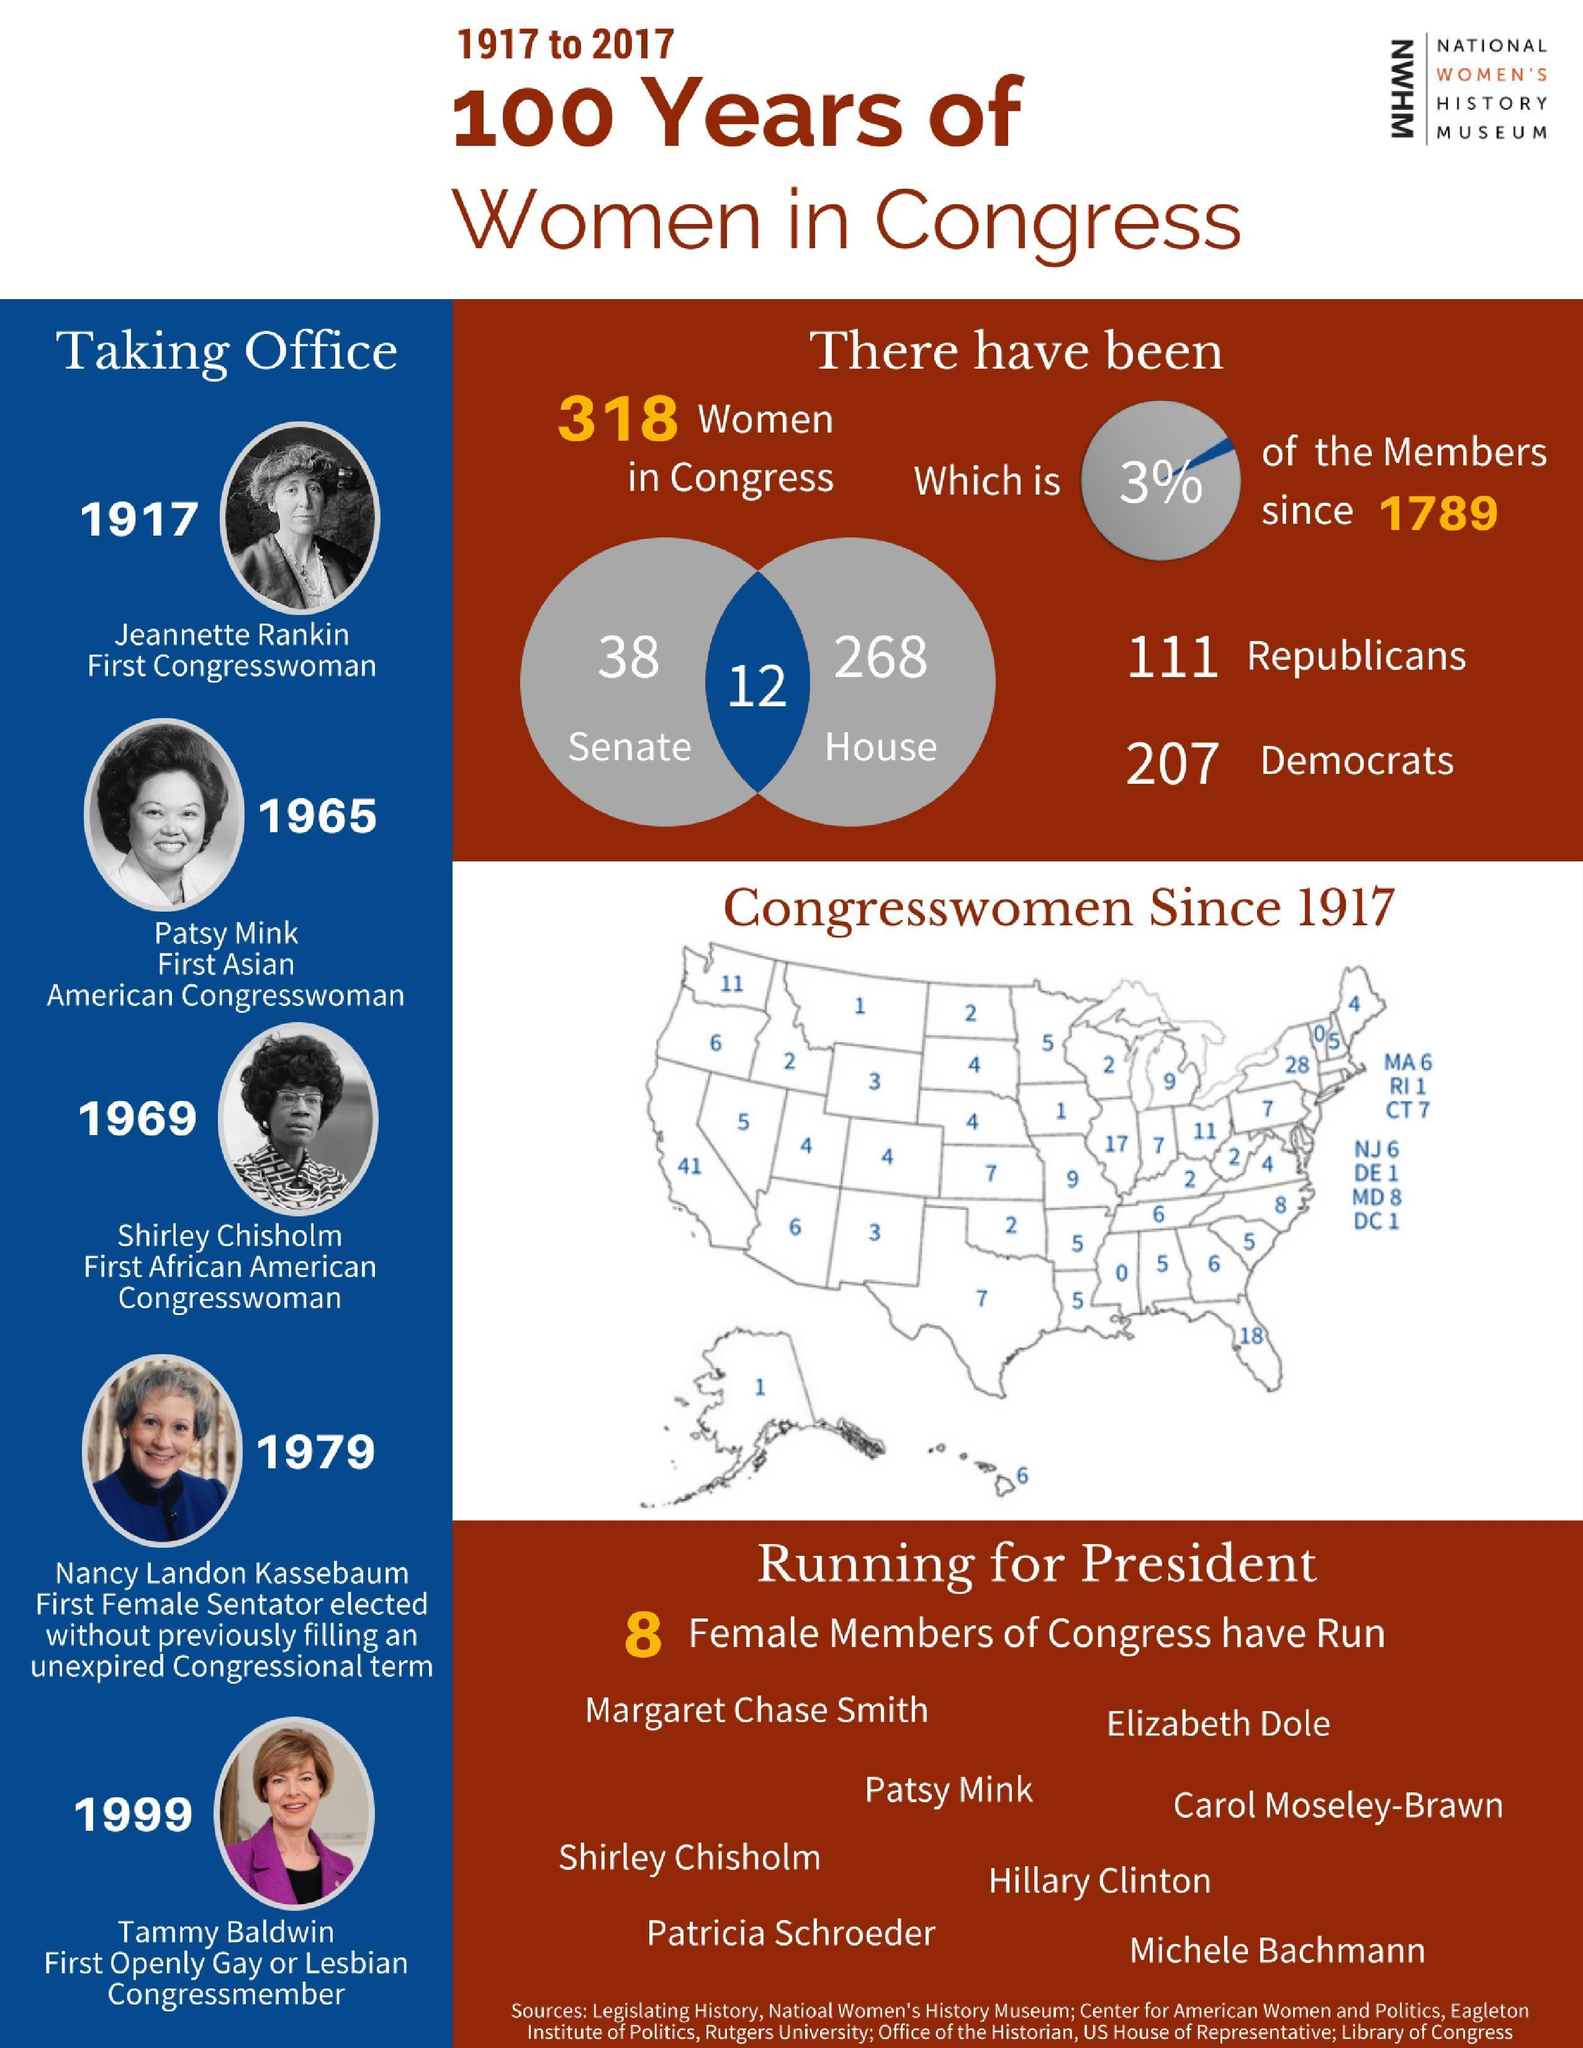How many female members were in the U.S. Senate from 1917 to 2017?
Answer the question with a short phrase. 38 When did the first African American Congresswoman took charge? 1969 How many congresswomen were from Texas during 1917-2017? 7 What percent of the members in the U.S. congress were women since 1789? 3% When did the first Asian American Congresswoman took charge? 1965 Who was the first openly gay or lesbian U.S. Congress member? Tammy Baldwin How many congresswomen were from Alaska from 1917 to 2017? 1 Who was the first woman elected to the U.S. Congress? Jeannette Rankin How many women in the U.S. Congress were Democrats from 1917 to 2017? 207 